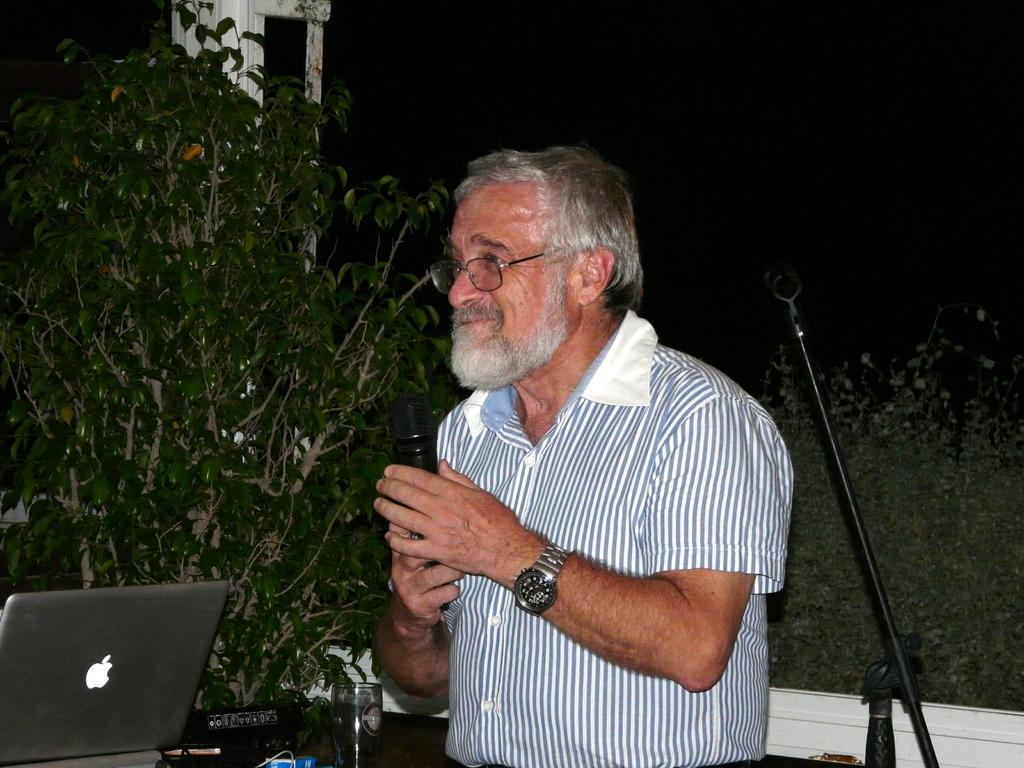How would you summarize this image in a sentence or two? In this picture there is a person holding microphone. We can see laptop. On the background we can see trees. This is sand. This is glass. 